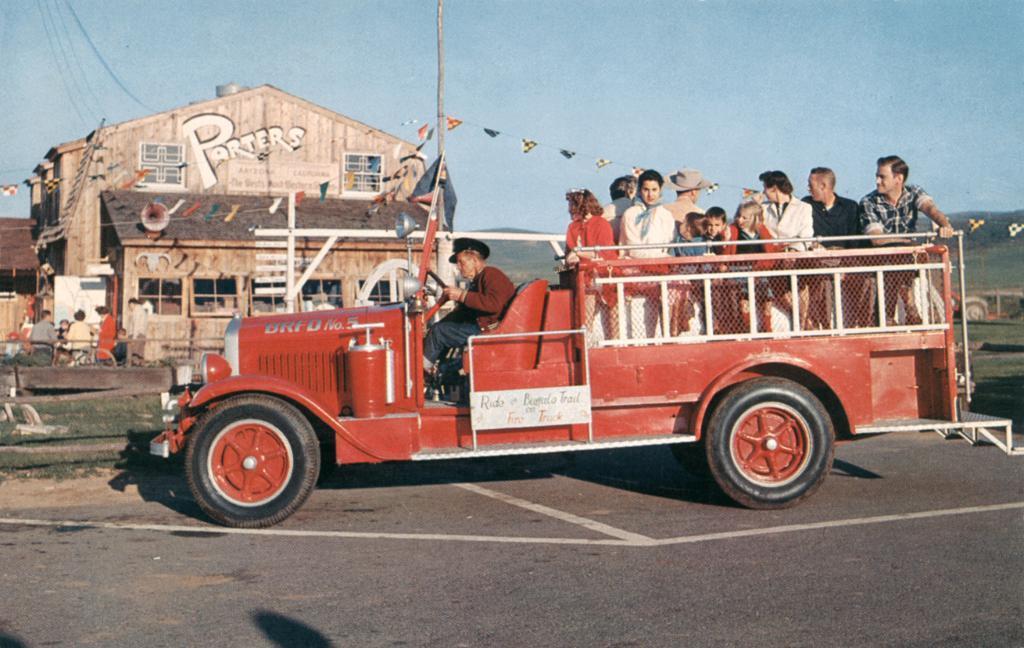Describe this image in one or two sentences. In the background we can see the sky. In this picture we can see a store, paper flags, windows, grass, pole, people and the road. We can see few people on a vehicle. 